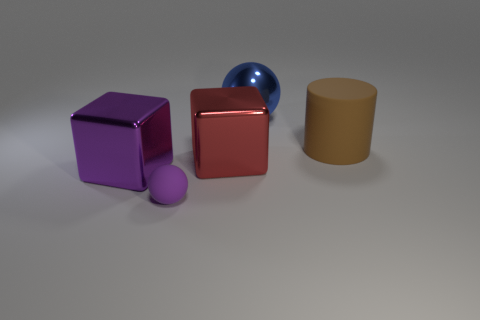What number of metal blocks are behind the purple block left of the cylinder that is behind the purple metallic block?
Offer a terse response. 1. There is a big thing that is the same color as the rubber sphere; what is it made of?
Ensure brevity in your answer.  Metal. Is there anything else that is the same shape as the big brown thing?
Make the answer very short. No. What number of objects are small purple matte spheres in front of the large blue metal thing or yellow cubes?
Your answer should be compact. 1. Do the object that is left of the small thing and the small rubber object have the same color?
Provide a short and direct response. Yes. What is the shape of the rubber object behind the rubber object that is to the left of the big ball?
Provide a succinct answer. Cylinder. Are there fewer red objects behind the large blue thing than small objects in front of the big purple block?
Keep it short and to the point. Yes. The purple matte object that is the same shape as the large blue object is what size?
Your answer should be compact. Small. Are there any other things that are the same size as the purple matte ball?
Provide a short and direct response. No. How many objects are objects that are behind the tiny purple matte ball or big objects behind the large purple cube?
Your answer should be very brief. 4. 